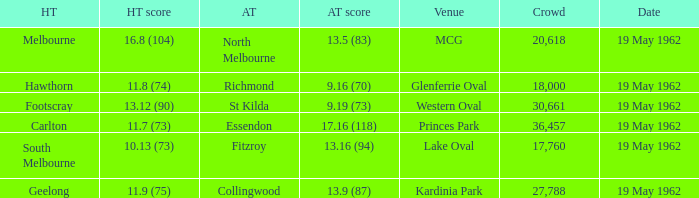What is the home team's score at mcg? 16.8 (104). 